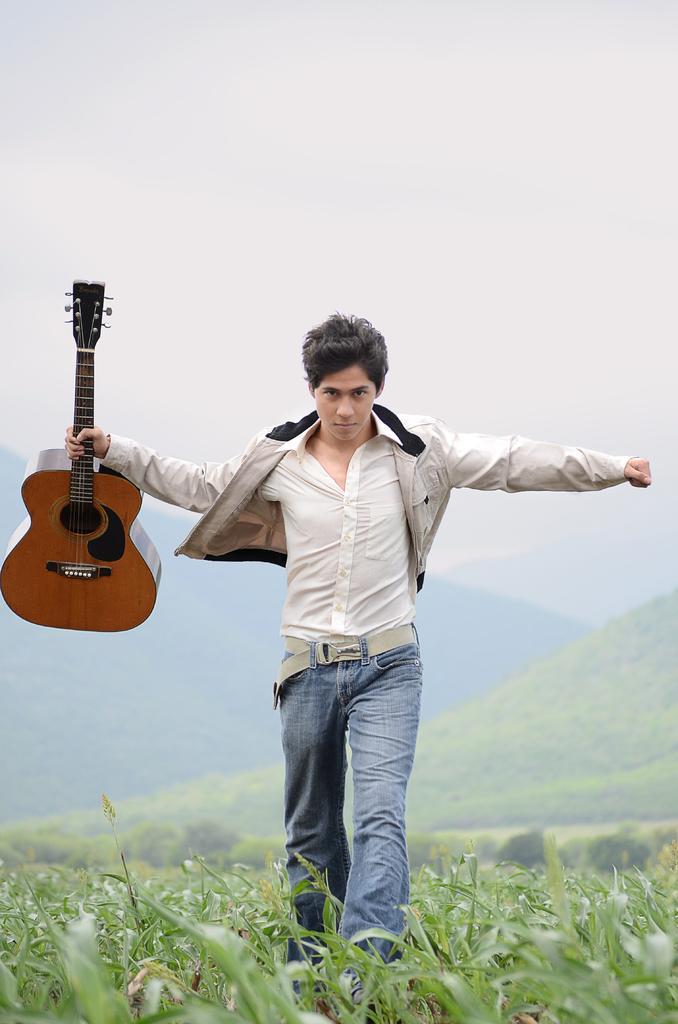Can you describe this image briefly? A boy with white jacket, white shirt and jeans pant is holding a guitar in his hand. He is walking on the grass. Behind him there are hills. 